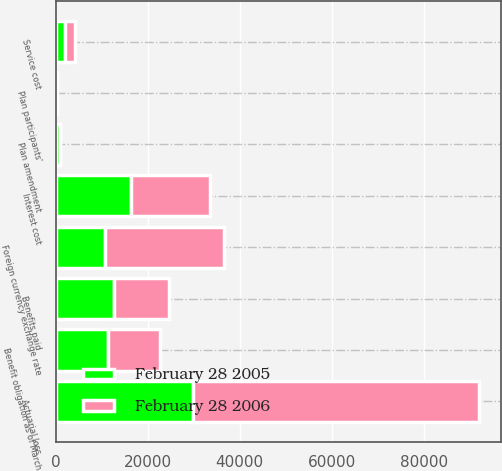<chart> <loc_0><loc_0><loc_500><loc_500><stacked_bar_chart><ecel><fcel>Benefit obligation as of March<fcel>Service cost<fcel>Interest cost<fcel>Plan participants'<fcel>Actuarial loss<fcel>Plan amendment<fcel>Benefits paid<fcel>Foreign currency exchange rate<nl><fcel>February 28 2006<fcel>11364.5<fcel>2149<fcel>17260<fcel>166<fcel>62194<fcel>38<fcel>11893<fcel>25837<nl><fcel>February 28 2005<fcel>11364.5<fcel>2117<fcel>16391<fcel>84<fcel>29939<fcel>884<fcel>12769<fcel>10836<nl></chart> 